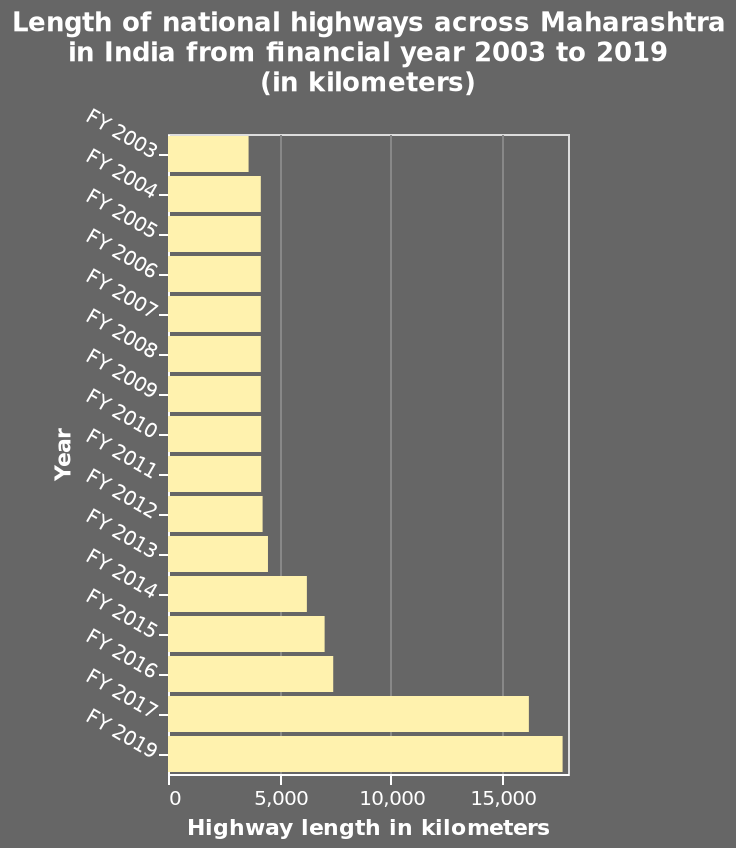<image>
What is the geographical region covered in the bar plot? The bar plot represents the national highways across Maharashtra in India. Offer a thorough analysis of the image. That the amount of roads/routes more than doubled in the time frame leading me to conclude that there may be more vehicles and more money available. How did the increase in road network impact the availability of vehicles and money? It led to the conclusion that there may be more vehicles and more money available. What is the minimum and maximum value on the x-axis? The minimum value on the x-axis is 0 and the maximum value is 15,000. 